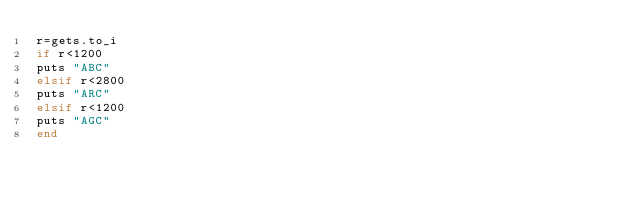<code> <loc_0><loc_0><loc_500><loc_500><_Ruby_>r=gets.to_i
if r<1200
puts "ABC"
elsif r<2800
puts "ARC"
elsif r<1200
puts "AGC"
end
</code> 